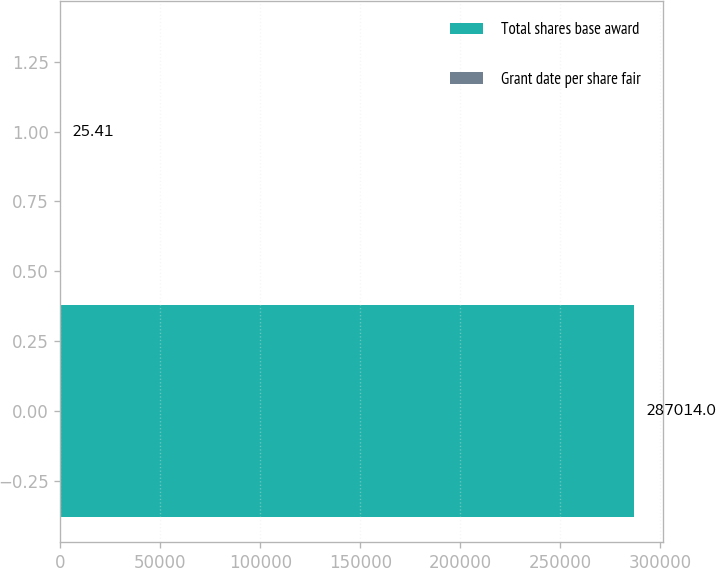<chart> <loc_0><loc_0><loc_500><loc_500><bar_chart><fcel>Total shares base award<fcel>Grant date per share fair<nl><fcel>287014<fcel>25.41<nl></chart> 